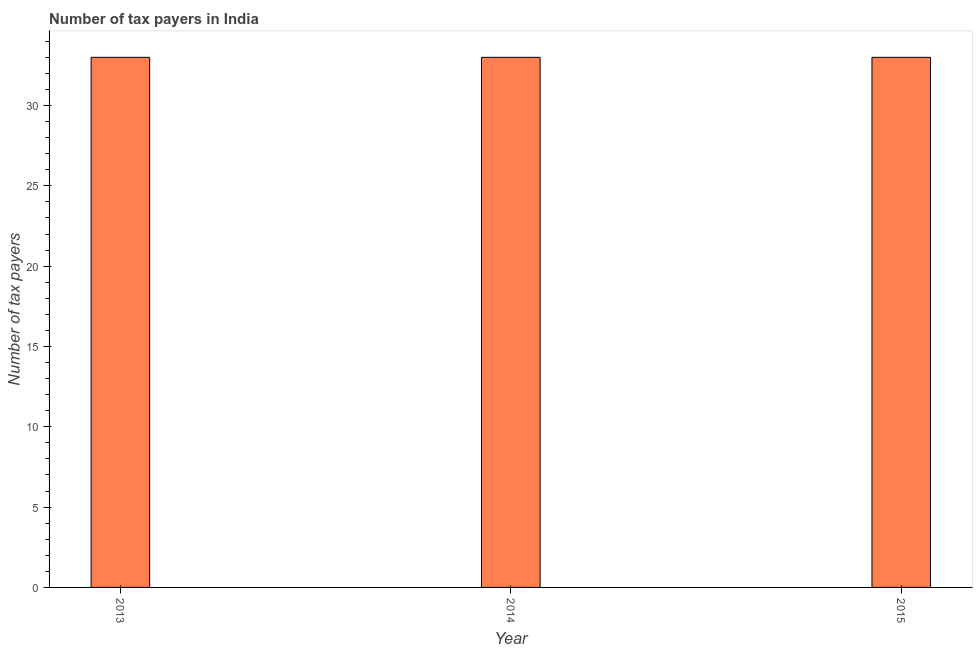Does the graph contain any zero values?
Your answer should be compact. No. Does the graph contain grids?
Give a very brief answer. No. What is the title of the graph?
Give a very brief answer. Number of tax payers in India. What is the label or title of the X-axis?
Give a very brief answer. Year. What is the label or title of the Y-axis?
Provide a short and direct response. Number of tax payers. What is the number of tax payers in 2015?
Provide a succinct answer. 33. In which year was the number of tax payers minimum?
Provide a short and direct response. 2013. What is the average number of tax payers per year?
Offer a very short reply. 33. Do a majority of the years between 2015 and 2014 (inclusive) have number of tax payers greater than 1 ?
Provide a short and direct response. No. What is the ratio of the number of tax payers in 2013 to that in 2014?
Keep it short and to the point. 1. In how many years, is the number of tax payers greater than the average number of tax payers taken over all years?
Offer a terse response. 0. How many bars are there?
Offer a very short reply. 3. What is the difference between two consecutive major ticks on the Y-axis?
Your answer should be compact. 5. What is the Number of tax payers in 2014?
Provide a succinct answer. 33. What is the Number of tax payers in 2015?
Your response must be concise. 33. What is the ratio of the Number of tax payers in 2013 to that in 2014?
Offer a terse response. 1. What is the ratio of the Number of tax payers in 2013 to that in 2015?
Provide a short and direct response. 1. 